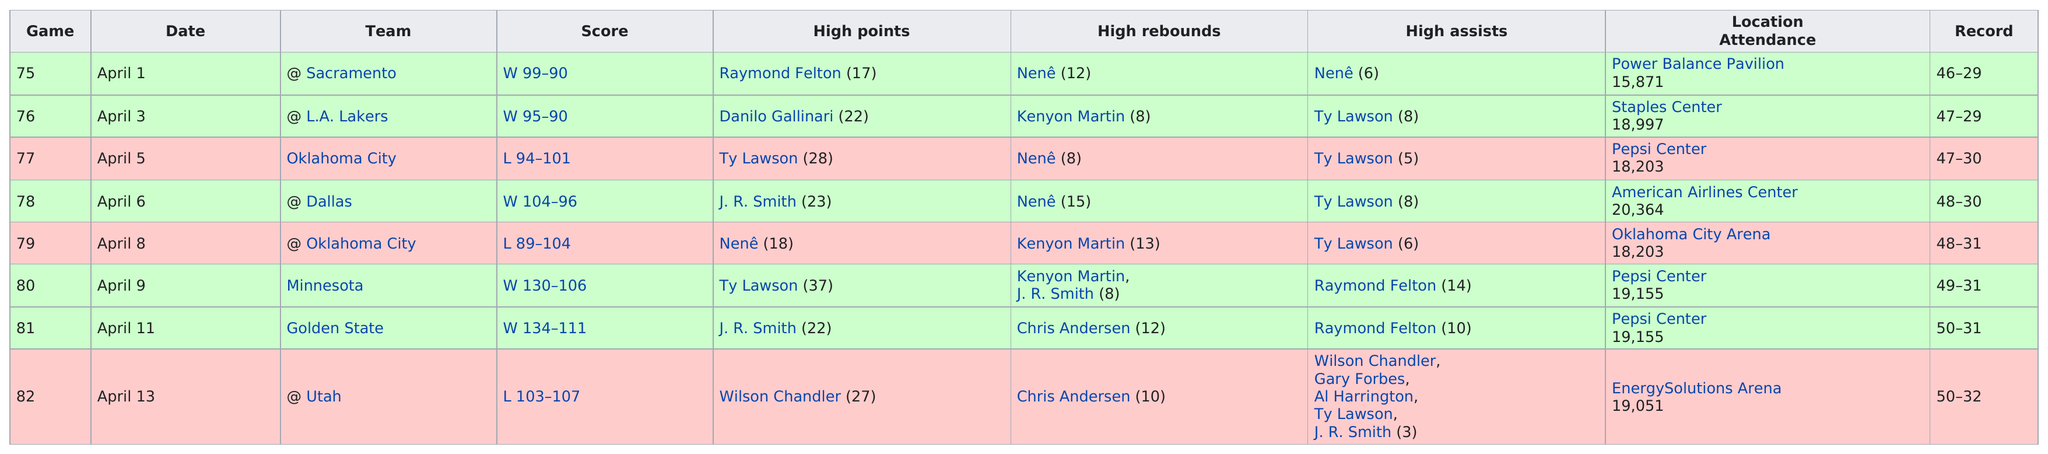Mention a couple of crucial points in this snapshot. The game after 81 is 82. During the month of April in this current season, the Denver team scored a grand total of 848 points. In how many games was the team defeated? Specifically, 3... In how many consecutive games was Ty Lawson the player with the most assists? Four. In April of this season, Kenyon Martin scored a total of 29 high rebounds, demonstrating his exceptional basketball skills and athleticism. 